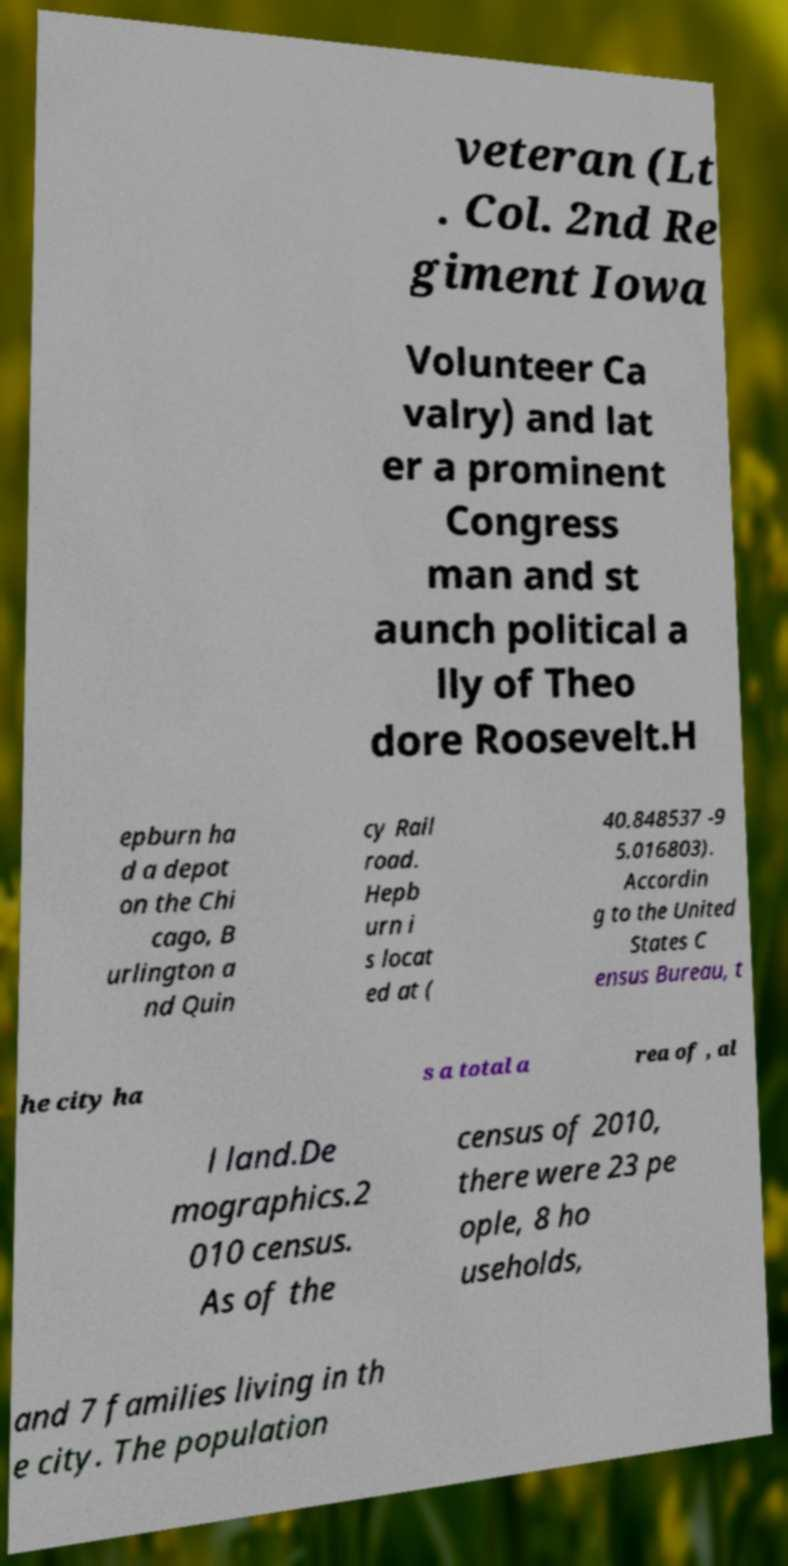For documentation purposes, I need the text within this image transcribed. Could you provide that? veteran (Lt . Col. 2nd Re giment Iowa Volunteer Ca valry) and lat er a prominent Congress man and st aunch political a lly of Theo dore Roosevelt.H epburn ha d a depot on the Chi cago, B urlington a nd Quin cy Rail road. Hepb urn i s locat ed at ( 40.848537 -9 5.016803). Accordin g to the United States C ensus Bureau, t he city ha s a total a rea of , al l land.De mographics.2 010 census. As of the census of 2010, there were 23 pe ople, 8 ho useholds, and 7 families living in th e city. The population 